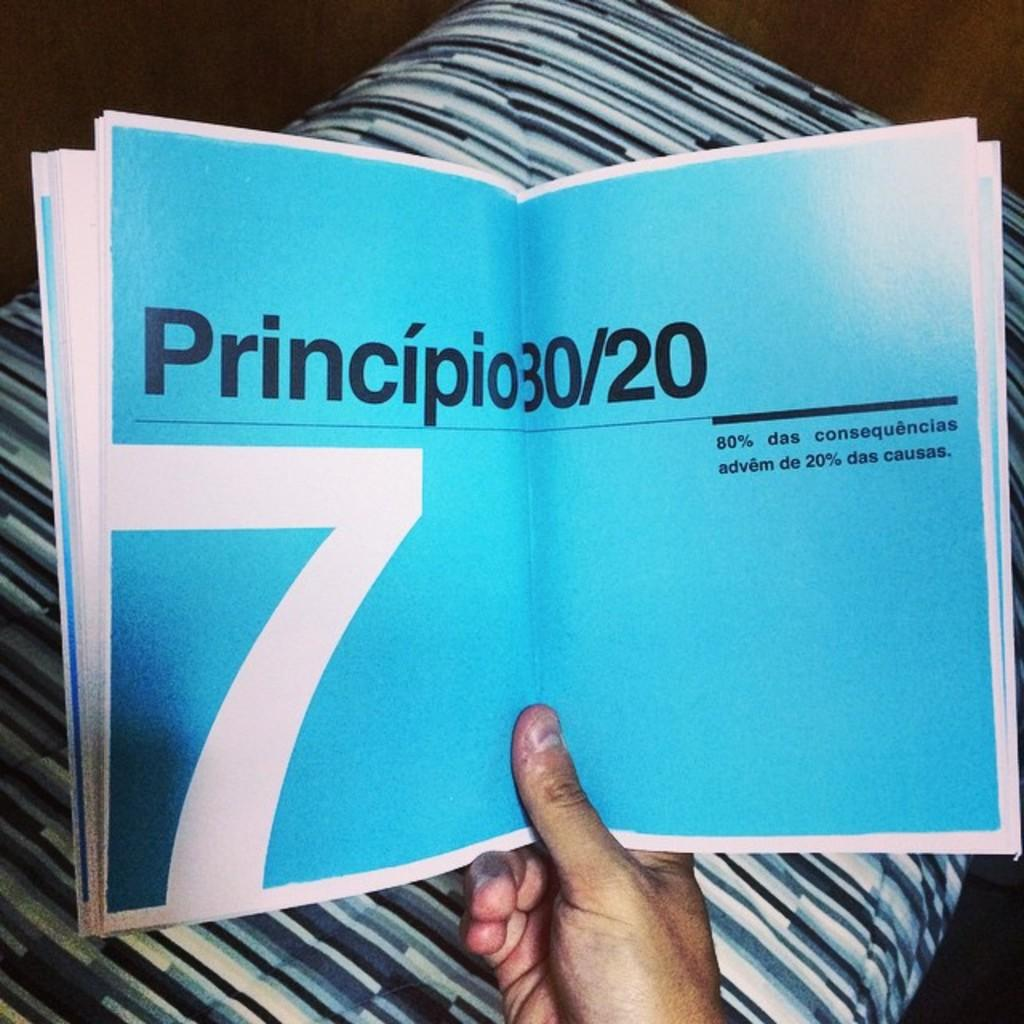<image>
Render a clear and concise summary of the photo. Someone is holding a book that includes a chapter about Principio 80/20. 